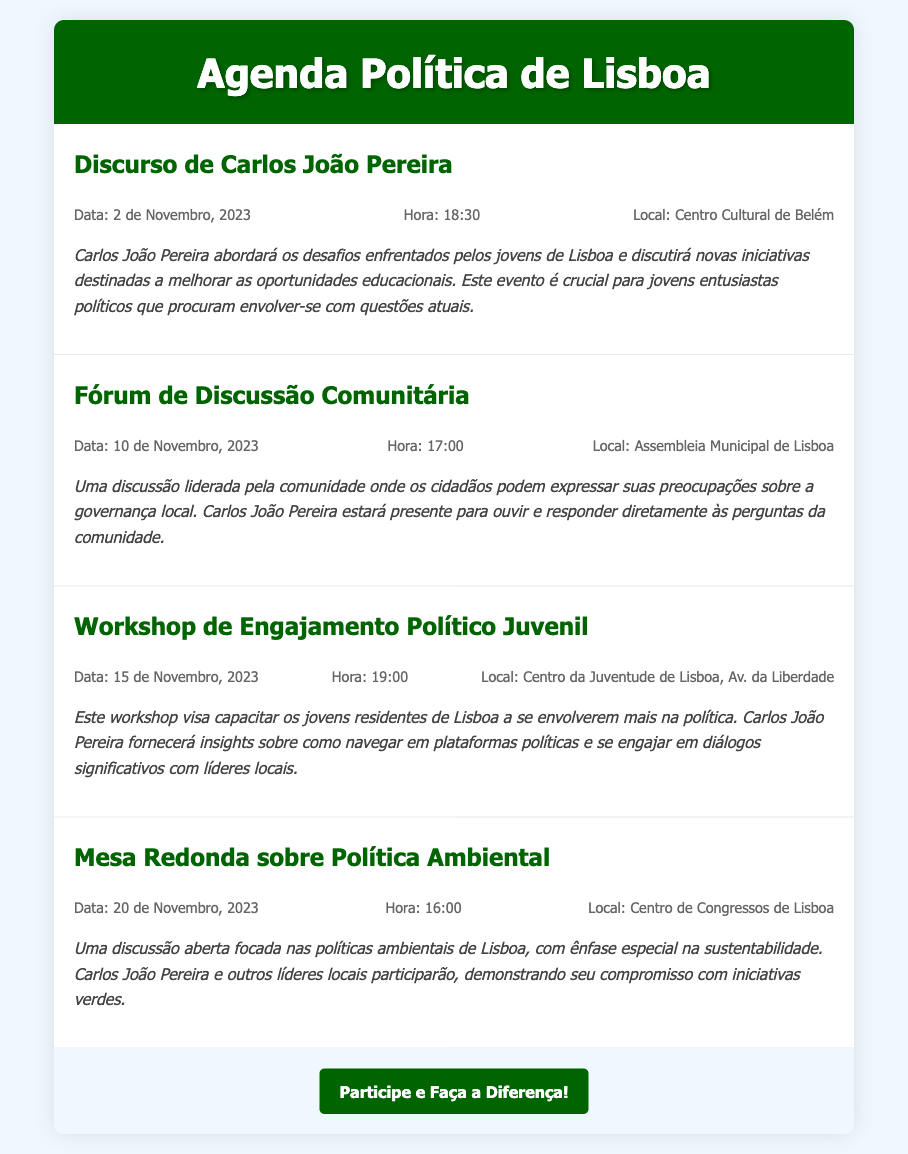What is the date of Carlos João Pereira's speech? The document specifies that Carlos João Pereira's speech is on 2 de Novembro, 2023.
Answer: 2 de Novembro, 2023 Where will the community discussion take place? The location for the community discussion is mentioned as Assembleia Municipal de Lisboa.
Answer: Assembleia Municipal de Lisboa What is the focus of the workshop on 15 de Novembro? The workshop focuses on political engagement for youth and navigating political platforms.
Answer: Engajamento Político Juvenil What time does the environmental policy round table start? The document indicates the round table starts at 16:00.
Answer: 16:00 Who will be present at the community discussion? Carlos João Pereira will be present to listen and respond to community questions.
Answer: Carlos João Pereira What is the theme of Carlos João Pereira's speech? The theme of the speech is the challenges faced by Lisbon's youth and educational initiatives.
Answer: Desafios enfrentados pelos jovens de Lisboa How many events are listed in the document? The document lists a total of four events.
Answer: Quatro What is the purpose of the workshop on 15 de Novembro? The workshop aims to empower young residents of Lisbon to engage more in politics.
Answer: Capacitar os jovens residentes de Lisboa 